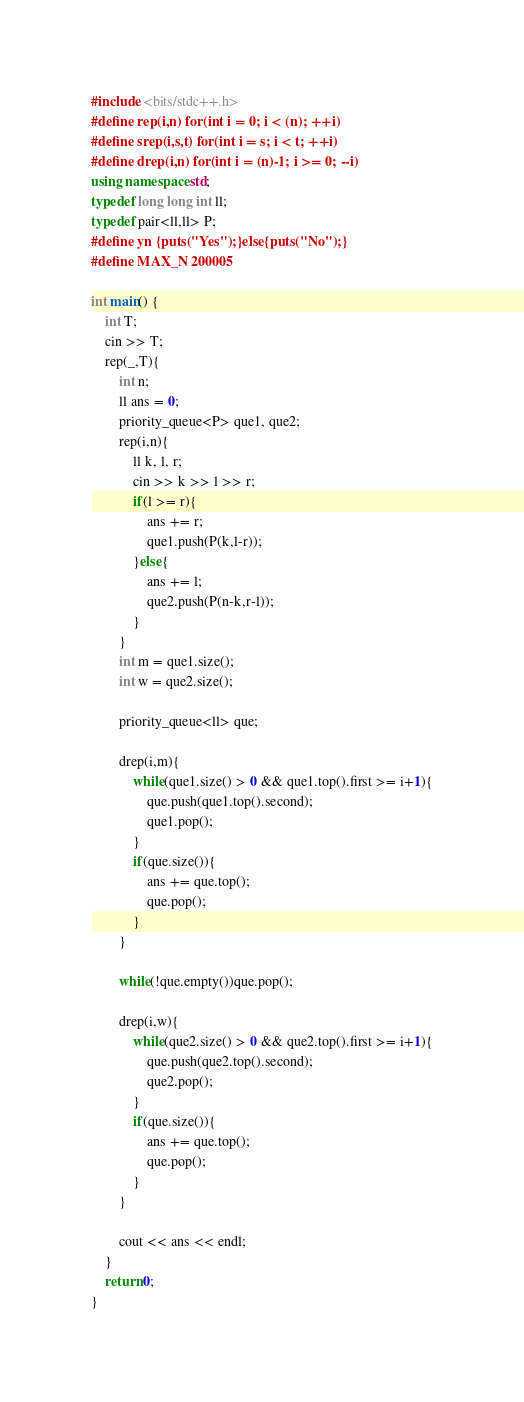<code> <loc_0><loc_0><loc_500><loc_500><_C++_>#include <bits/stdc++.h>
#define rep(i,n) for(int i = 0; i < (n); ++i)
#define srep(i,s,t) for(int i = s; i < t; ++i)
#define drep(i,n) for(int i = (n)-1; i >= 0; --i)
using namespace std;
typedef long long int ll;
typedef pair<ll,ll> P;
#define yn {puts("Yes");}else{puts("No");}
#define MAX_N 200005

int main() {
    int T;
    cin >> T;
    rep(_,T){
        int n;
        ll ans = 0;
        priority_queue<P> que1, que2;
        rep(i,n){
            ll k, l, r;
            cin >> k >> l >> r;
            if(l >= r){
                ans += r;
                que1.push(P(k,l-r));
            }else{
                ans += l;
                que2.push(P(n-k,r-l));
            }
        }
        int m = que1.size();
        int w = que2.size();

        priority_queue<ll> que;

        drep(i,m){
            while(que1.size() > 0 && que1.top().first >= i+1){
                que.push(que1.top().second);
                que1.pop();
            }
            if(que.size()){
                ans += que.top();
                que.pop();
            }
        }

        while(!que.empty())que.pop();

        drep(i,w){
            while(que2.size() > 0 && que2.top().first >= i+1){
                que.push(que2.top().second);
                que2.pop();
            }
            if(que.size()){
                ans += que.top();
                que.pop();
            }
        }

        cout << ans << endl;
    }
    return 0;
}


</code> 